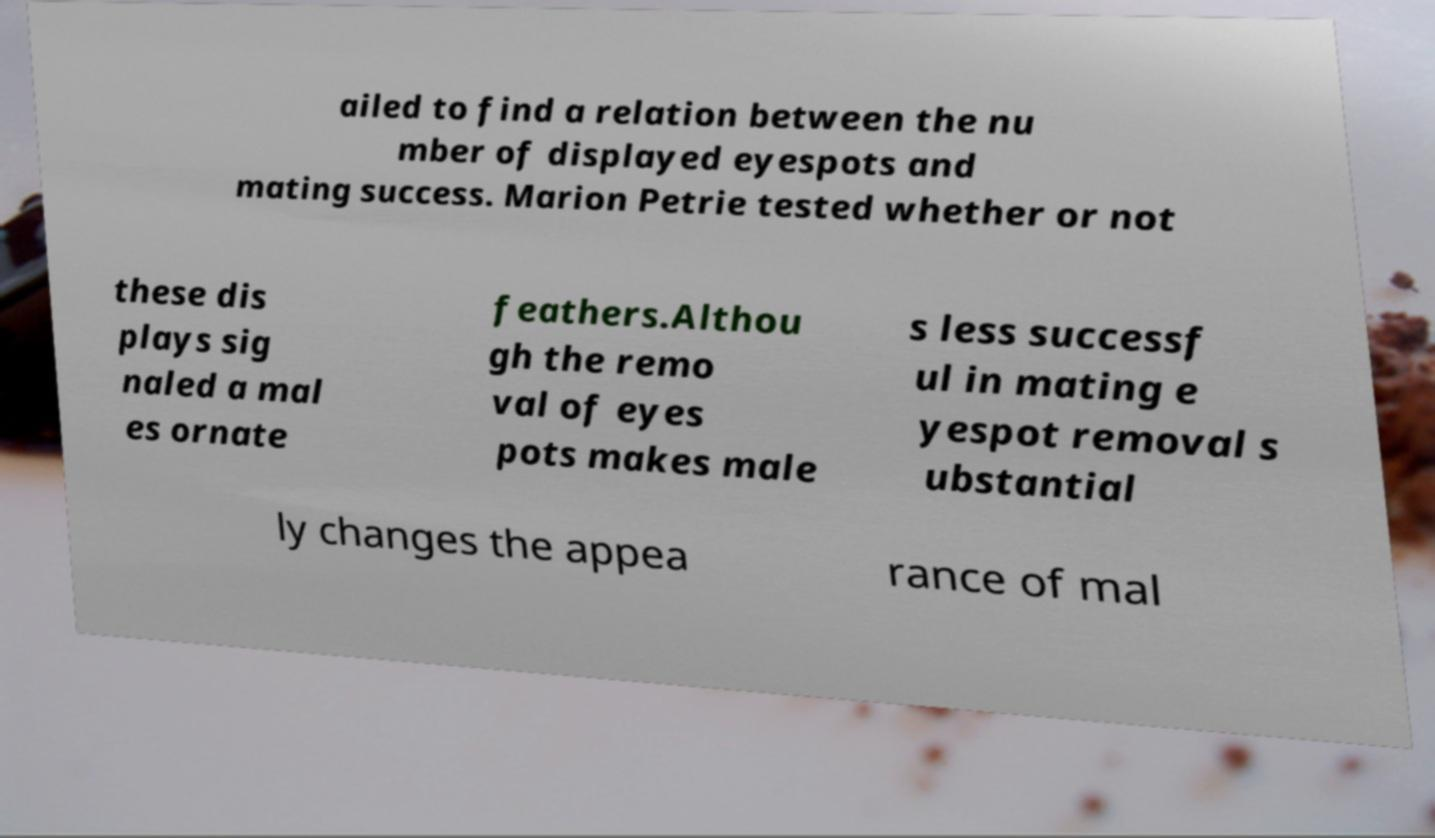Please identify and transcribe the text found in this image. ailed to find a relation between the nu mber of displayed eyespots and mating success. Marion Petrie tested whether or not these dis plays sig naled a mal es ornate feathers.Althou gh the remo val of eyes pots makes male s less successf ul in mating e yespot removal s ubstantial ly changes the appea rance of mal 